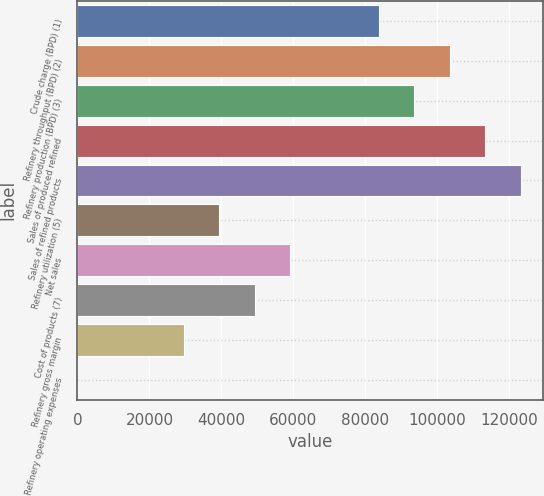Convert chart to OTSL. <chart><loc_0><loc_0><loc_500><loc_500><bar_chart><fcel>Crude charge (BPD) (1)<fcel>Refinery throughput (BPD) (2)<fcel>Refinery production (BPD) (3)<fcel>Sales of produced refined<fcel>Sales of refined products<fcel>Refinery utilization (5)<fcel>Net sales<fcel>Cost of products (7)<fcel>Refinery gross margin<fcel>Refinery operating expenses<nl><fcel>83700<fcel>103407<fcel>93553.5<fcel>113260<fcel>123114<fcel>39419.3<fcel>59126.2<fcel>49272.7<fcel>29565.8<fcel>5.44<nl></chart> 